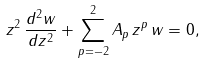Convert formula to latex. <formula><loc_0><loc_0><loc_500><loc_500>z ^ { 2 } \, \frac { d ^ { 2 } w } { d z ^ { 2 } } + \sum _ { p = - 2 } ^ { 2 } A _ { p } \, z ^ { p } \, w = 0 ,</formula> 